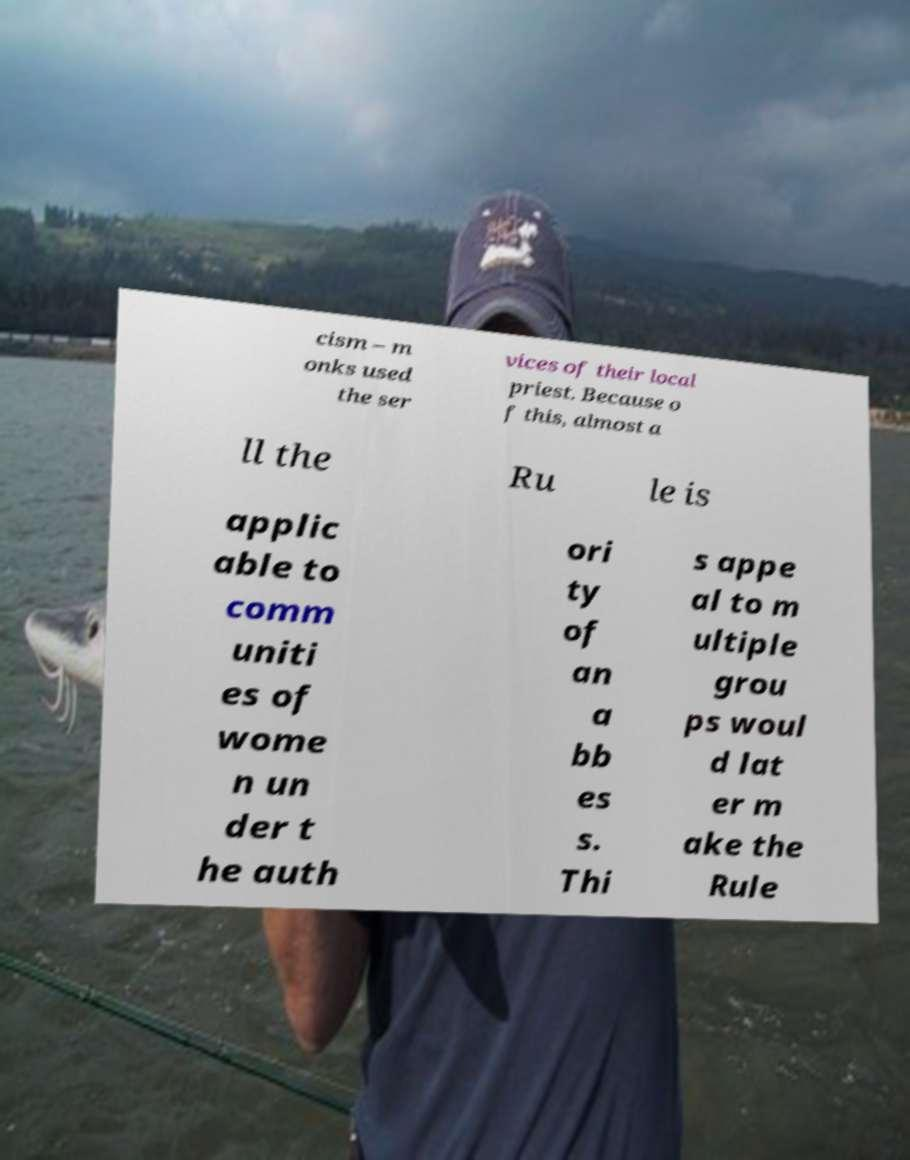Could you assist in decoding the text presented in this image and type it out clearly? cism – m onks used the ser vices of their local priest. Because o f this, almost a ll the Ru le is applic able to comm uniti es of wome n un der t he auth ori ty of an a bb es s. Thi s appe al to m ultiple grou ps woul d lat er m ake the Rule 